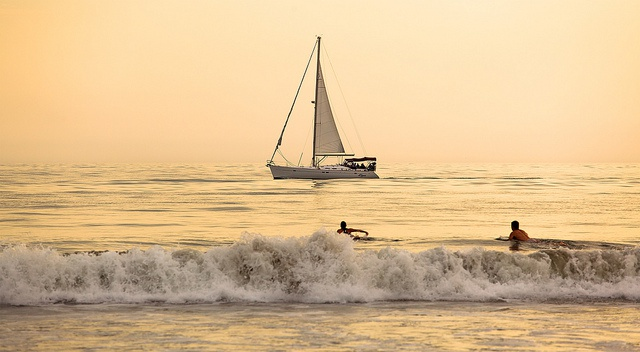Describe the objects in this image and their specific colors. I can see boat in tan, gray, black, and khaki tones, people in tan, khaki, black, and maroon tones, people in tan, maroon, black, and brown tones, surfboard in tan, maroon, black, and gray tones, and surfboard in tan, gray, and black tones in this image. 